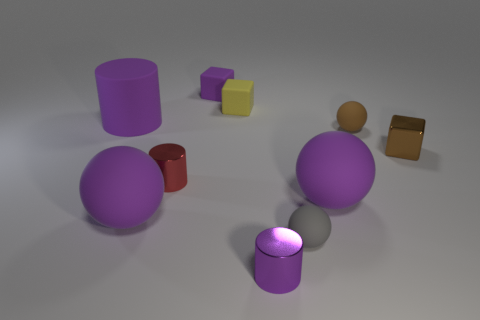Is there any other thing that has the same color as the metal block?
Give a very brief answer. Yes. There is a large rubber cylinder; is its color the same as the ball behind the tiny metal cube?
Offer a terse response. No. Are there fewer red metallic things that are on the right side of the tiny brown block than gray rubber things?
Provide a short and direct response. Yes. What material is the sphere to the left of the yellow rubber cube?
Provide a succinct answer. Rubber. What number of other things are there of the same size as the yellow matte thing?
Offer a terse response. 6. Does the purple metallic cylinder have the same size as the purple cylinder that is behind the brown rubber ball?
Your response must be concise. No. There is a metallic object in front of the big rubber ball that is on the right side of the gray rubber thing on the left side of the metallic cube; what shape is it?
Your response must be concise. Cylinder. Are there fewer purple things than tiny metallic objects?
Make the answer very short. No. There is a brown rubber object; are there any yellow objects behind it?
Make the answer very short. Yes. What is the shape of the tiny object that is in front of the tiny brown cube and right of the tiny purple shiny thing?
Provide a short and direct response. Sphere. 